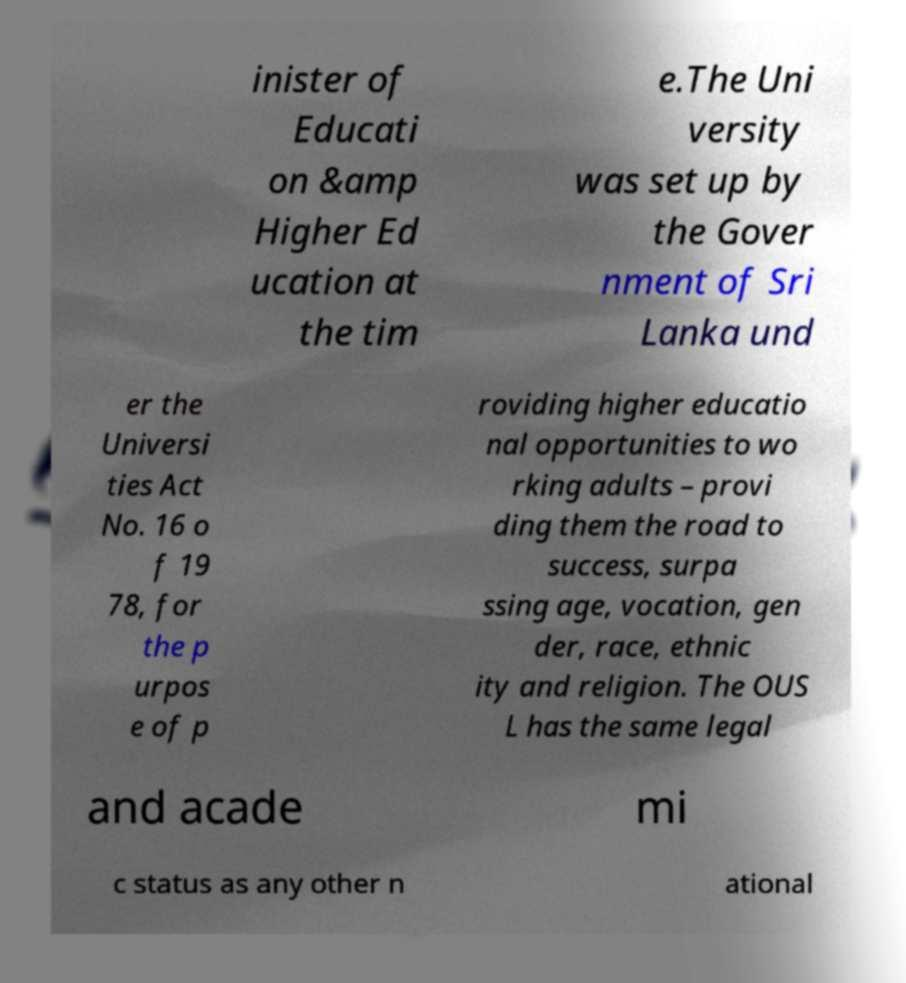I need the written content from this picture converted into text. Can you do that? inister of Educati on &amp Higher Ed ucation at the tim e.The Uni versity was set up by the Gover nment of Sri Lanka und er the Universi ties Act No. 16 o f 19 78, for the p urpos e of p roviding higher educatio nal opportunities to wo rking adults – provi ding them the road to success, surpa ssing age, vocation, gen der, race, ethnic ity and religion. The OUS L has the same legal and acade mi c status as any other n ational 